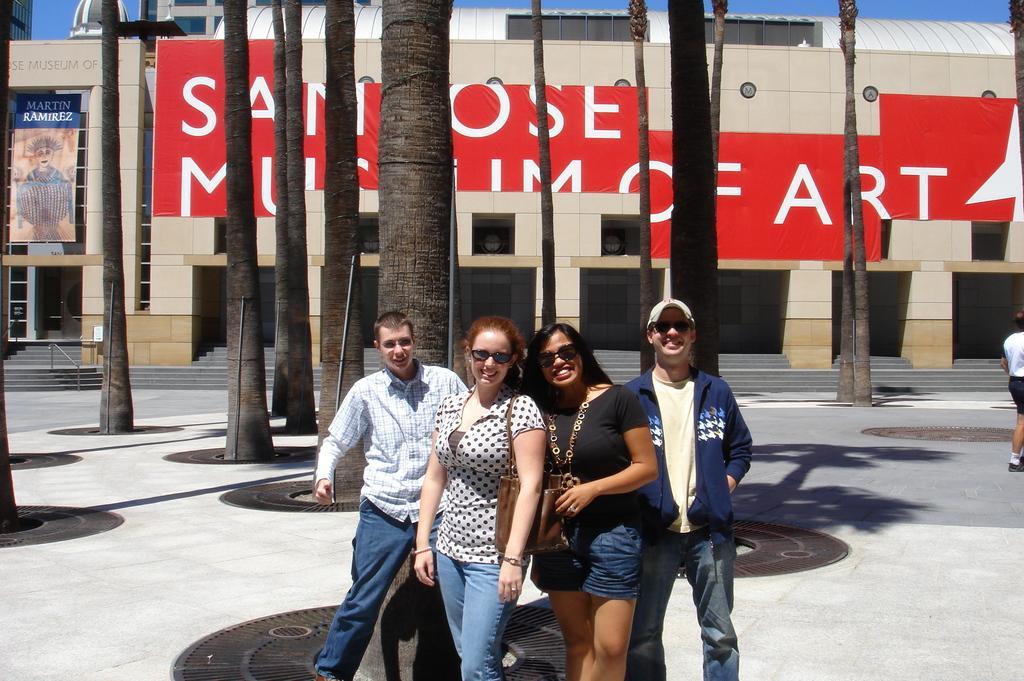Describe this image in one or two sentences. In the middle of the image there are few people standing and they kept goggles. And also there is a man with a cap on the head. Behind them there are tree trunks. Behind them there is a building with walls, posters, banners with something written on it. And also there are steps and pillars. 